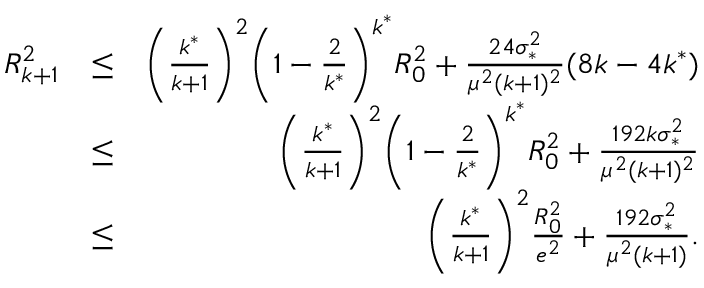Convert formula to latex. <formula><loc_0><loc_0><loc_500><loc_500>\begin{array} { r l r } { R _ { k + 1 } ^ { 2 } } & { \leq } & { \left ( \frac { k ^ { * } } { k + 1 } \right ) ^ { 2 } \left ( 1 - \frac { 2 } { k ^ { * } } \right ) ^ { k ^ { * } } R _ { 0 } ^ { 2 } + \frac { 2 4 \sigma _ { * } ^ { 2 } } { \mu ^ { 2 } ( k + 1 ) ^ { 2 } } ( 8 k - 4 k ^ { * } ) } \\ & { \leq } & { \left ( \frac { k ^ { * } } { k + 1 } \right ) ^ { 2 } \left ( 1 - \frac { 2 } { k ^ { * } } \right ) ^ { k ^ { * } } R _ { 0 } ^ { 2 } + \frac { 1 9 2 k \sigma _ { * } ^ { 2 } } { \mu ^ { 2 } ( k + 1 ) ^ { 2 } } } \\ & { \leq } & { \left ( \frac { k ^ { * } } { k + 1 } \right ) ^ { 2 } \frac { R _ { 0 } ^ { 2 } } { e ^ { 2 } } + \frac { 1 9 2 \sigma _ { * } ^ { 2 } } { \mu ^ { 2 } ( k + 1 ) } . } \end{array}</formula> 